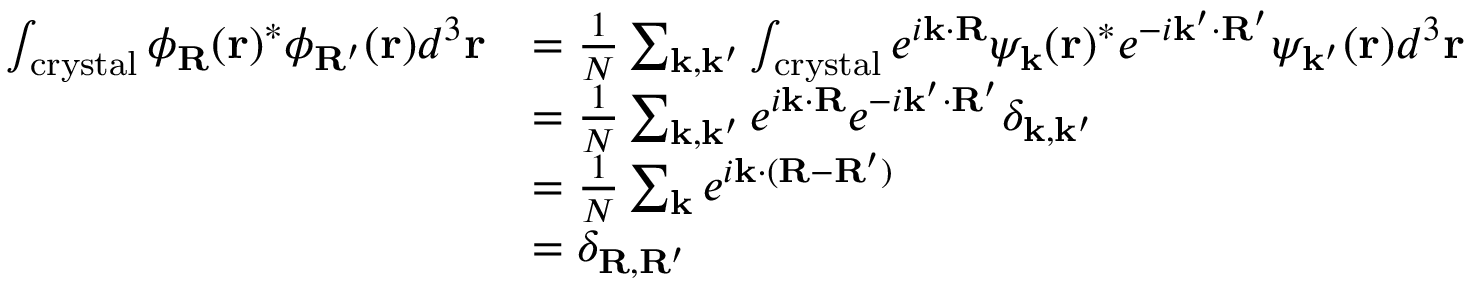<formula> <loc_0><loc_0><loc_500><loc_500>{ \begin{array} { r l } { \int _ { c r y s t a l } \phi _ { R } ( r ) ^ { * } \phi _ { R ^ { \prime } } ( r ) d ^ { 3 } r } & { = { \frac { 1 } { N } } \sum _ { k , k ^ { \prime } } \int _ { c r y s t a l } e ^ { i k \cdot R } \psi _ { k } ( r ) ^ { * } e ^ { - i k ^ { \prime } \cdot R ^ { \prime } } \psi _ { k ^ { \prime } } ( r ) d ^ { 3 } r } \\ & { = { \frac { 1 } { N } } \sum _ { k , k ^ { \prime } } e ^ { i k \cdot R } e ^ { - i k ^ { \prime } \cdot R ^ { \prime } } \delta _ { k , k ^ { \prime } } } \\ & { = { \frac { 1 } { N } } \sum _ { k } e ^ { i k \cdot ( R - R ^ { \prime } ) } } \\ & { = \delta _ { R , R ^ { \prime } } } \end{array} }</formula> 